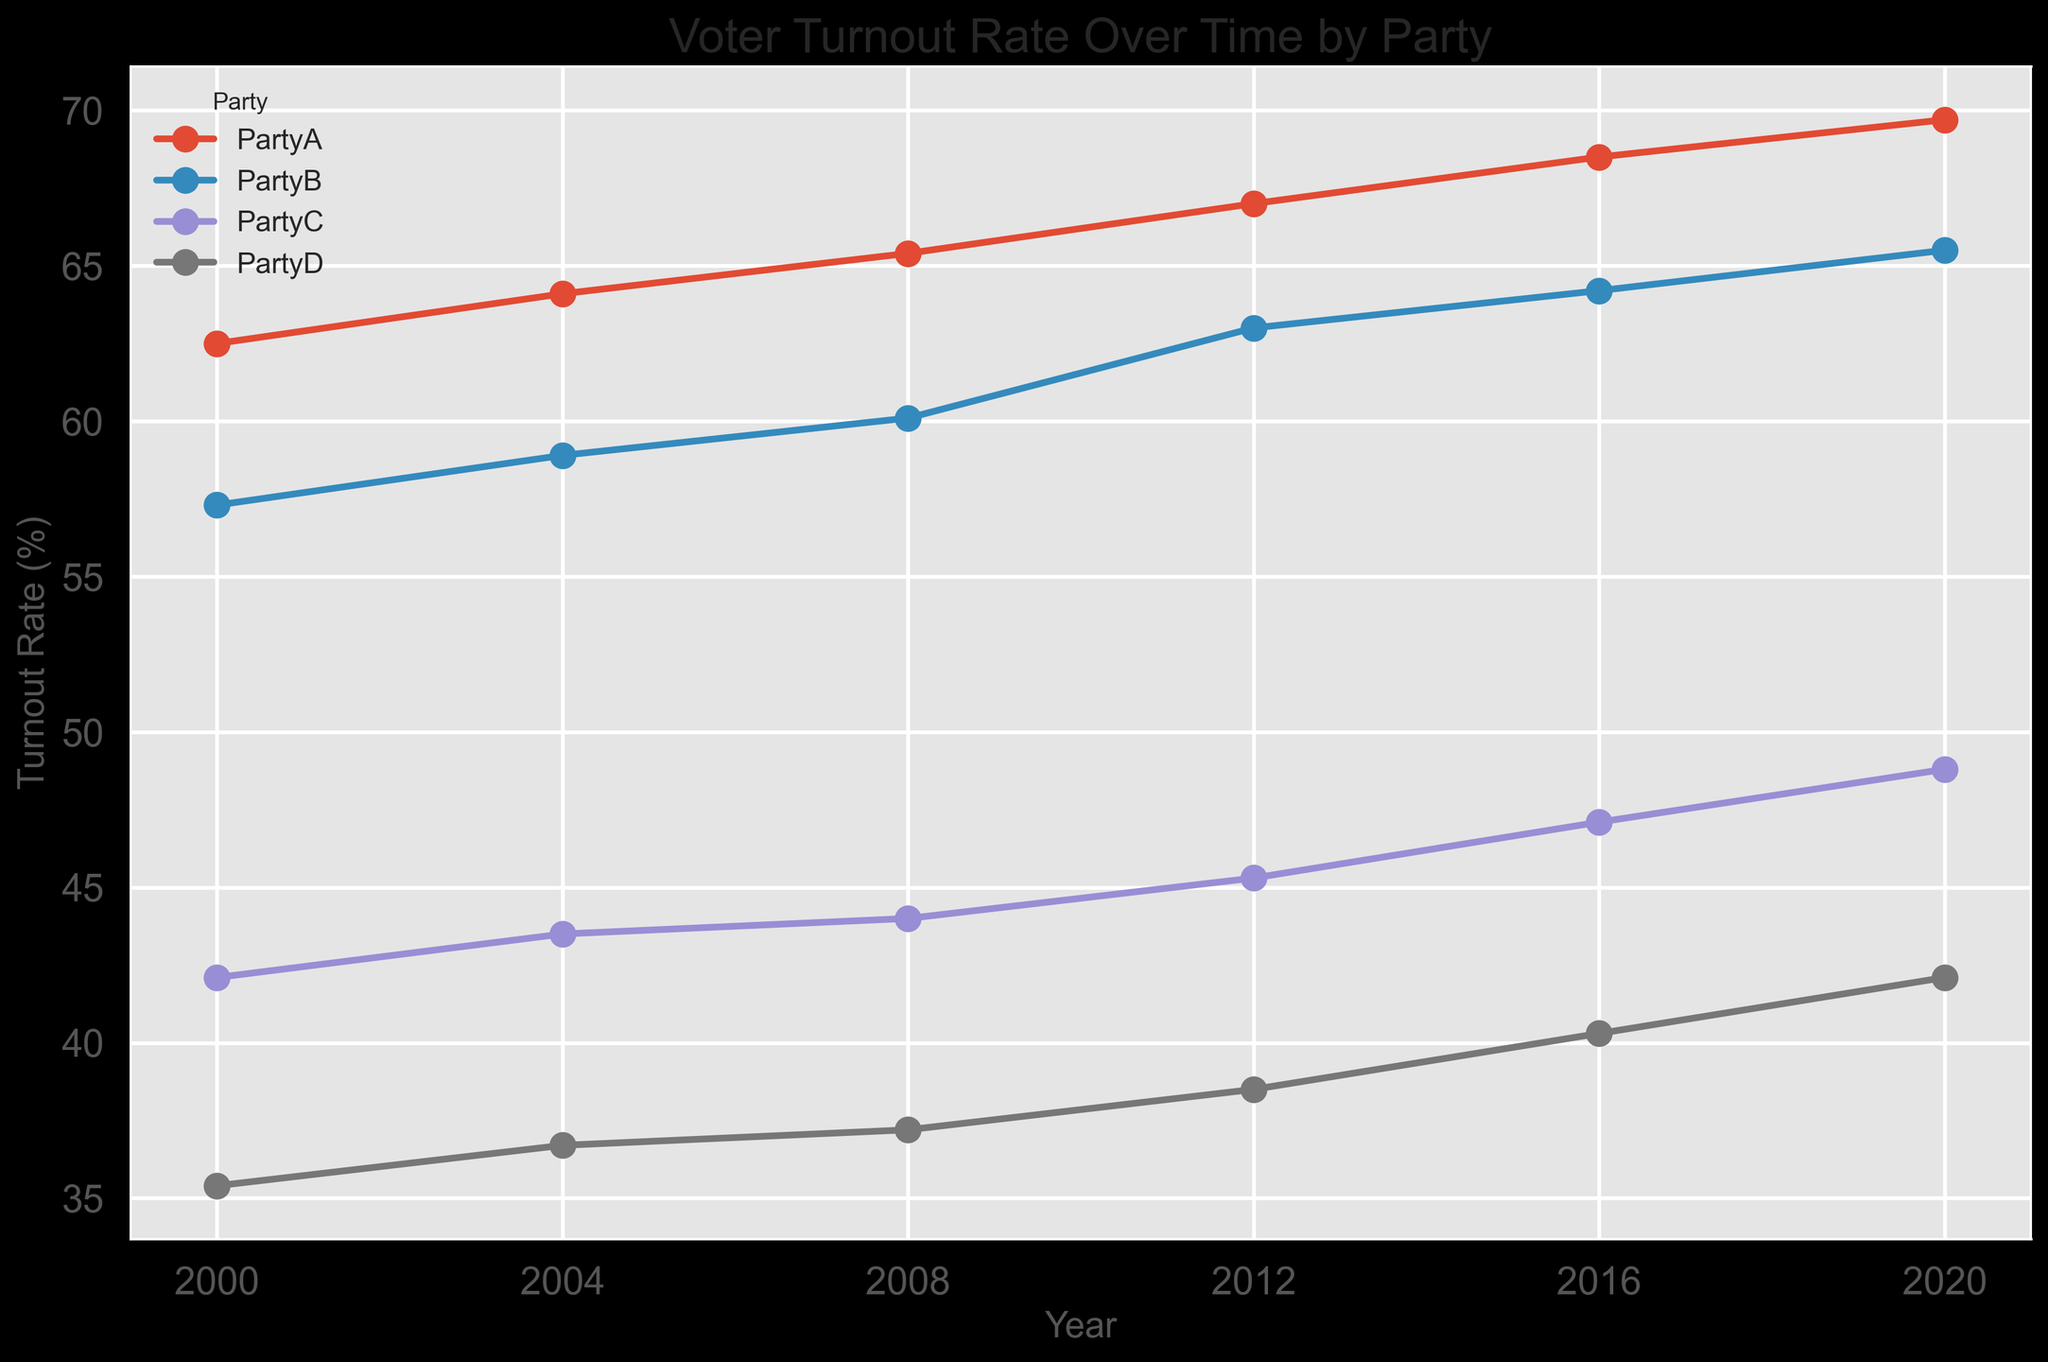What is the voter turnout rate for Party A in 2012? Look at the plot and find the turnout rate value for Party A in 2012 by locating the intersection of the Party A line and the 2012 year mark on the x-axis.
Answer: 67.0% Which party had the lowest voter turnout rate in 2000? Identify the turnout rates for all parties in 2000 by locating their respective points on the plot. Compare these values to determine the lowest rate.
Answer: PartyD How much did the voter turnout rate for Party B increase from 2008 to 2020? Find the turnout rates for Party B in 2008 and 2020, which are 60.1% and 65.5%, respectively. Subtract the 2008 rate from the 2020 rate to find the increase: 65.5% - 60.1% = 5.4%
Answer: 5.4% Which party showed the greatest increase in voter turnout rate from 2000 to 2020? Calculate the difference in turnout rates from 2000 to 2020 for each party. Compare these differences to determine which party has the highest increase.
Answer: PartyD What is the combined voter turnout rate for Party C across all years? Sum the turnout rates for Party C for each year: 42.1 + 43.5 + 44.0 + 45.3 + 47.1 + 48.8 = 270.8%.
Answer: 270.8% Which party had a higher voter turnout rate in 2016, Party C or Party D? Locate the turnout rates for Party C and Party D in 2016, then compare them. Party C has 47.1%, and Party D has 40.3%.
Answer: Party C What is the average voter turnout rate for Party A over the years? Sum the turnout rates for Party A across all years, then divide by the number of years: (62.5 + 64.1 + 65.4 + 67.0 + 68.5 + 69.7) / 6 = 66.2%.
Answer: 66.2% Did any party achieve a voter turnout rate above 60% in 2000? Check each party’s turnout rate in 2000. Party A had 62.5%, Party B had 57.3%, Party C had 42.1%, and Party D had 35.4%. Only Party A is above 60%.
Answer: Yes Which party had the most consistent voter turnout rate changes over the years? Look at the plot and observe the fluctuation in each party's line graph. Party D's line shows the most consistent and gradual upward trend.
Answer: Party D What is the difference in voter turnout rate for Party A between 2000 and 2016? Subtract the 2000 rate from the 2016 rate for Party A: 68.5% - 62.5% = 6.0%.
Answer: 6.0% 